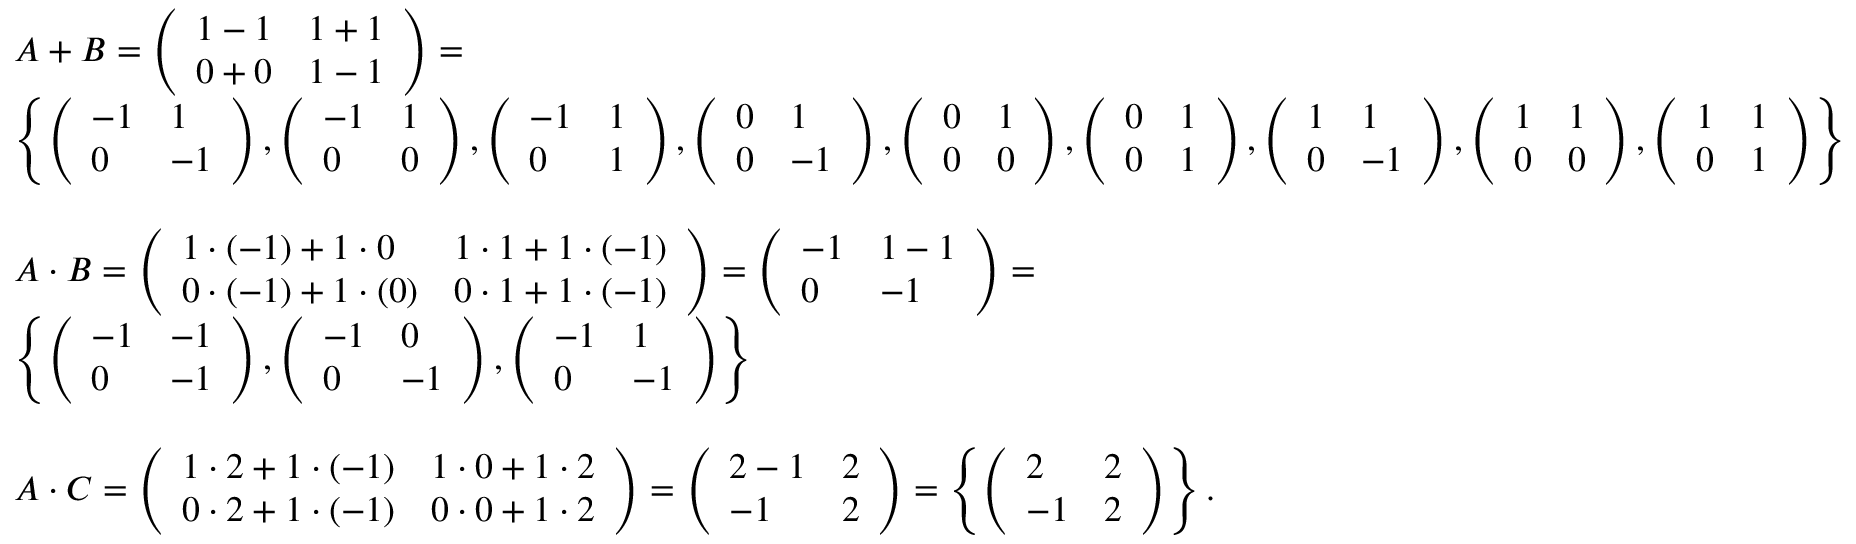<formula> <loc_0><loc_0><loc_500><loc_500>\begin{array} { r l } & { A + B = \left ( \begin{array} { l l } { 1 - 1 } & { 1 + 1 } \\ { 0 + 0 } & { 1 - 1 } \end{array} \right ) = } \\ & { \left \{ \left ( \begin{array} { l l } { - 1 } & { 1 } \\ { 0 } & { - 1 } \end{array} \right ) , \left ( \begin{array} { l l } { - 1 } & { 1 } \\ { 0 } & { 0 } \end{array} \right ) , \left ( \begin{array} { l l } { - 1 } & { 1 } \\ { 0 } & { 1 } \end{array} \right ) , \left ( \begin{array} { l l } { 0 } & { 1 } \\ { 0 } & { - 1 } \end{array} \right ) , \left ( \begin{array} { l l } { 0 } & { 1 } \\ { 0 } & { 0 } \end{array} \right ) , \left ( \begin{array} { l l } { 0 } & { 1 } \\ { 0 } & { 1 } \end{array} \right ) , \left ( \begin{array} { l l } { 1 } & { 1 } \\ { 0 } & { - 1 } \end{array} \right ) , \left ( \begin{array} { l l } { 1 } & { 1 } \\ { 0 } & { 0 } \end{array} \right ) , \left ( \begin{array} { l l } { 1 } & { 1 } \\ { 0 } & { 1 } \end{array} \right ) \right \} } \\ { \quad } \\ & { A \cdot B = \left ( \begin{array} { l l } { 1 \cdot ( - 1 ) + 1 \cdot 0 } & { 1 \cdot 1 + 1 \cdot ( - 1 ) } \\ { 0 \cdot ( - 1 ) + 1 \cdot ( 0 ) } & { 0 \cdot 1 + 1 \cdot ( - 1 ) } \end{array} \right ) = \left ( \begin{array} { l l } { - 1 } & { 1 - 1 } \\ { 0 } & { - 1 } \end{array} \right ) = } \\ & { \left \{ \left ( \begin{array} { l l } { - 1 } & { - 1 } \\ { 0 } & { - 1 } \end{array} \right ) , \left ( \begin{array} { l l } { - 1 } & { 0 } \\ { 0 } & { - 1 } \end{array} \right ) , \left ( \begin{array} { l l } { - 1 } & { 1 } \\ { 0 } & { - 1 } \end{array} \right ) \right \} } \\ { \quad } \\ & { A \cdot C = \left ( \begin{array} { l l } { 1 \cdot 2 + 1 \cdot ( - 1 ) } & { 1 \cdot 0 + 1 \cdot 2 } \\ { 0 \cdot 2 + 1 \cdot ( - 1 ) } & { 0 \cdot 0 + 1 \cdot 2 } \end{array} \right ) = \left ( \begin{array} { l l } { 2 - 1 } & { 2 } \\ { - 1 } & { 2 } \end{array} \right ) = \left \{ \left ( \begin{array} { l l } { 2 } & { 2 } \\ { - 1 } & { 2 } \end{array} \right ) \right \} . } \end{array}</formula> 